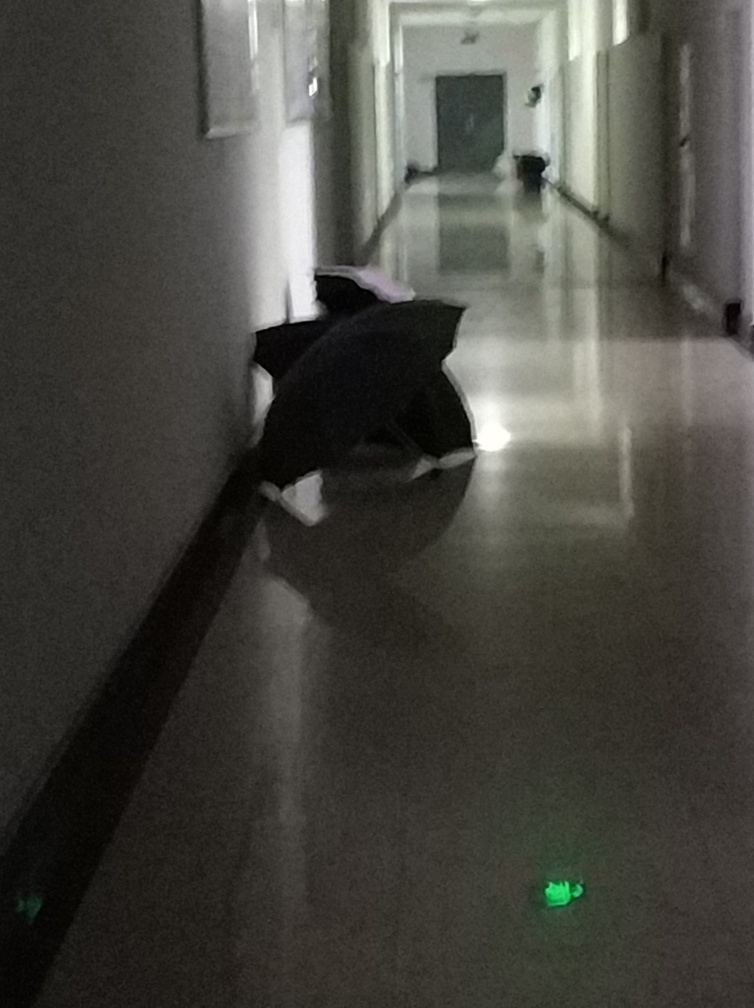What atmosphere does the image convey and what could enhance its clarity? The image exudes a somber and mysterious atmosphere, heightened by the shadows and minimal lighting. Its clarity could be enhanced by increasing the lighting in the corridor, using a camera with a higher sensitivity to low light, or employing a longer exposure to capture more detail. Editing techniques such as adjusting contrast, brightness, and sharpness could also help to make the details more discernible. 